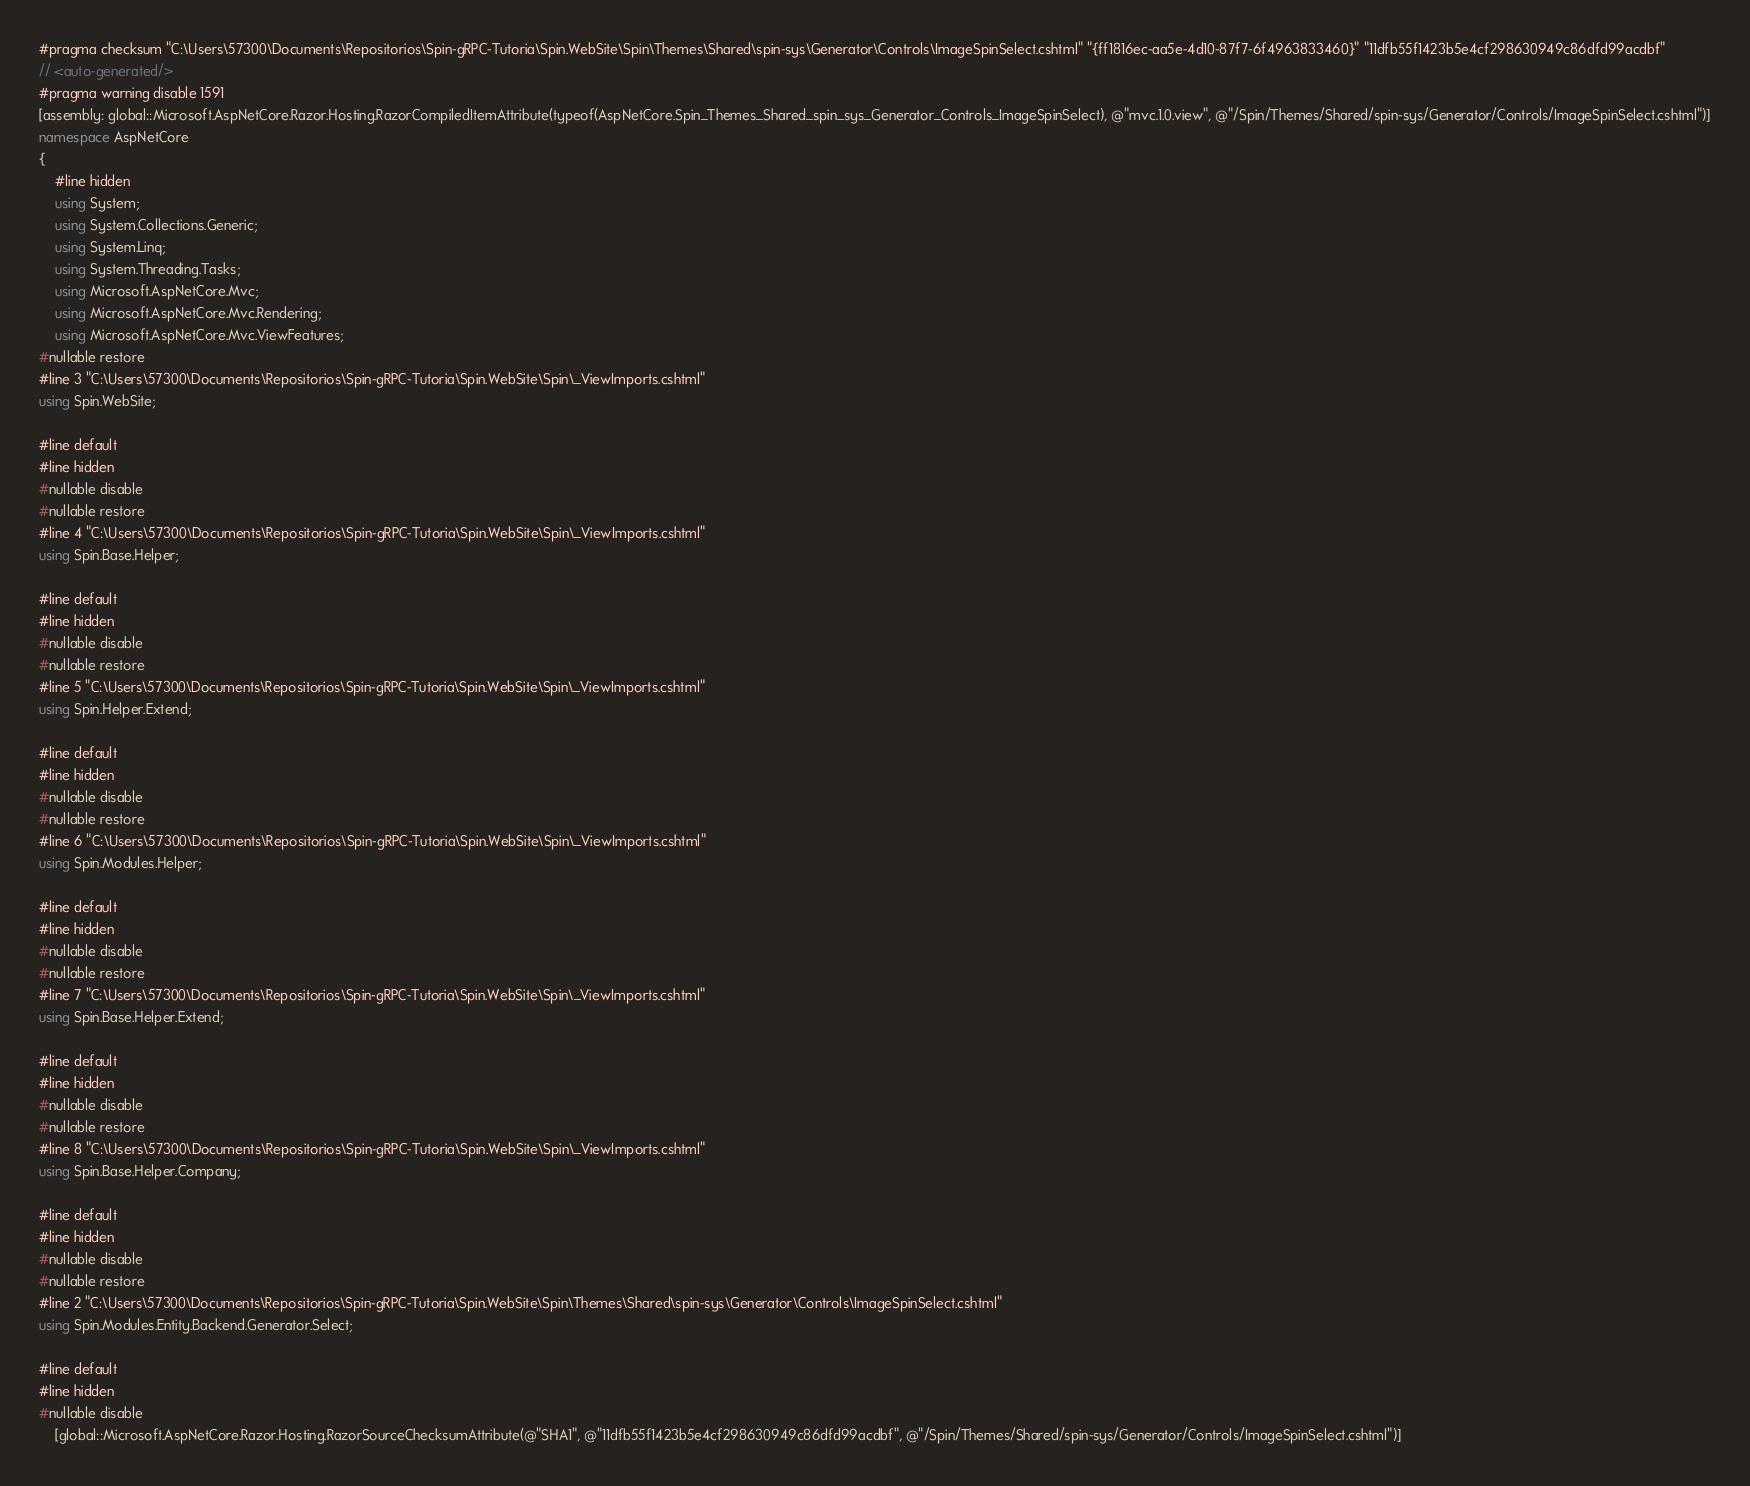Convert code to text. <code><loc_0><loc_0><loc_500><loc_500><_C#_>#pragma checksum "C:\Users\57300\Documents\Repositorios\Spin-gRPC-Tutoria\Spin.WebSite\Spin\Themes\Shared\spin-sys\Generator\Controls\ImageSpinSelect.cshtml" "{ff1816ec-aa5e-4d10-87f7-6f4963833460}" "11dfb55f1423b5e4cf298630949c86dfd99acdbf"
// <auto-generated/>
#pragma warning disable 1591
[assembly: global::Microsoft.AspNetCore.Razor.Hosting.RazorCompiledItemAttribute(typeof(AspNetCore.Spin_Themes_Shared_spin_sys_Generator_Controls_ImageSpinSelect), @"mvc.1.0.view", @"/Spin/Themes/Shared/spin-sys/Generator/Controls/ImageSpinSelect.cshtml")]
namespace AspNetCore
{
    #line hidden
    using System;
    using System.Collections.Generic;
    using System.Linq;
    using System.Threading.Tasks;
    using Microsoft.AspNetCore.Mvc;
    using Microsoft.AspNetCore.Mvc.Rendering;
    using Microsoft.AspNetCore.Mvc.ViewFeatures;
#nullable restore
#line 3 "C:\Users\57300\Documents\Repositorios\Spin-gRPC-Tutoria\Spin.WebSite\Spin\_ViewImports.cshtml"
using Spin.WebSite;

#line default
#line hidden
#nullable disable
#nullable restore
#line 4 "C:\Users\57300\Documents\Repositorios\Spin-gRPC-Tutoria\Spin.WebSite\Spin\_ViewImports.cshtml"
using Spin.Base.Helper;

#line default
#line hidden
#nullable disable
#nullable restore
#line 5 "C:\Users\57300\Documents\Repositorios\Spin-gRPC-Tutoria\Spin.WebSite\Spin\_ViewImports.cshtml"
using Spin.Helper.Extend;

#line default
#line hidden
#nullable disable
#nullable restore
#line 6 "C:\Users\57300\Documents\Repositorios\Spin-gRPC-Tutoria\Spin.WebSite\Spin\_ViewImports.cshtml"
using Spin.Modules.Helper;

#line default
#line hidden
#nullable disable
#nullable restore
#line 7 "C:\Users\57300\Documents\Repositorios\Spin-gRPC-Tutoria\Spin.WebSite\Spin\_ViewImports.cshtml"
using Spin.Base.Helper.Extend;

#line default
#line hidden
#nullable disable
#nullable restore
#line 8 "C:\Users\57300\Documents\Repositorios\Spin-gRPC-Tutoria\Spin.WebSite\Spin\_ViewImports.cshtml"
using Spin.Base.Helper.Company;

#line default
#line hidden
#nullable disable
#nullable restore
#line 2 "C:\Users\57300\Documents\Repositorios\Spin-gRPC-Tutoria\Spin.WebSite\Spin\Themes\Shared\spin-sys\Generator\Controls\ImageSpinSelect.cshtml"
using Spin.Modules.Entity.Backend.Generator.Select;

#line default
#line hidden
#nullable disable
    [global::Microsoft.AspNetCore.Razor.Hosting.RazorSourceChecksumAttribute(@"SHA1", @"11dfb55f1423b5e4cf298630949c86dfd99acdbf", @"/Spin/Themes/Shared/spin-sys/Generator/Controls/ImageSpinSelect.cshtml")]</code> 